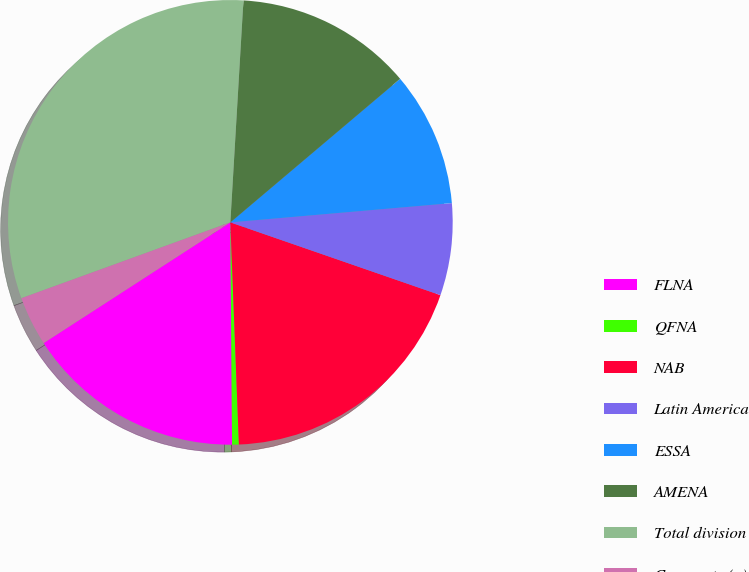<chart> <loc_0><loc_0><loc_500><loc_500><pie_chart><fcel>FLNA<fcel>QFNA<fcel>NAB<fcel>Latin America<fcel>ESSA<fcel>AMENA<fcel>Total division<fcel>Corporate (a)<nl><fcel>15.99%<fcel>0.49%<fcel>19.08%<fcel>6.69%<fcel>9.79%<fcel>12.89%<fcel>31.48%<fcel>3.59%<nl></chart> 